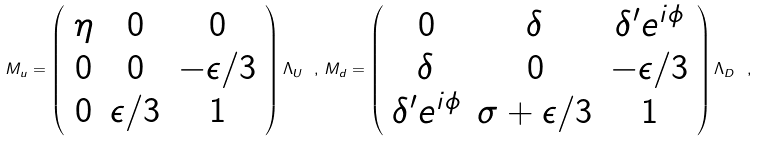Convert formula to latex. <formula><loc_0><loc_0><loc_500><loc_500>M _ { u } = \left ( \begin{array} { c c c } \eta & 0 & 0 \\ 0 & 0 & - \epsilon / 3 \\ 0 & \epsilon / 3 & 1 \end{array} \right ) \Lambda _ { U } \ , \, M _ { d } = \left ( \begin{array} { c c c } 0 & \delta & \delta ^ { \prime } e ^ { i \phi } \\ \delta & 0 & - \epsilon / 3 \\ \delta ^ { \prime } e ^ { i \phi } & \sigma + \epsilon / 3 & 1 \end{array} \right ) \Lambda _ { D } \ ,</formula> 